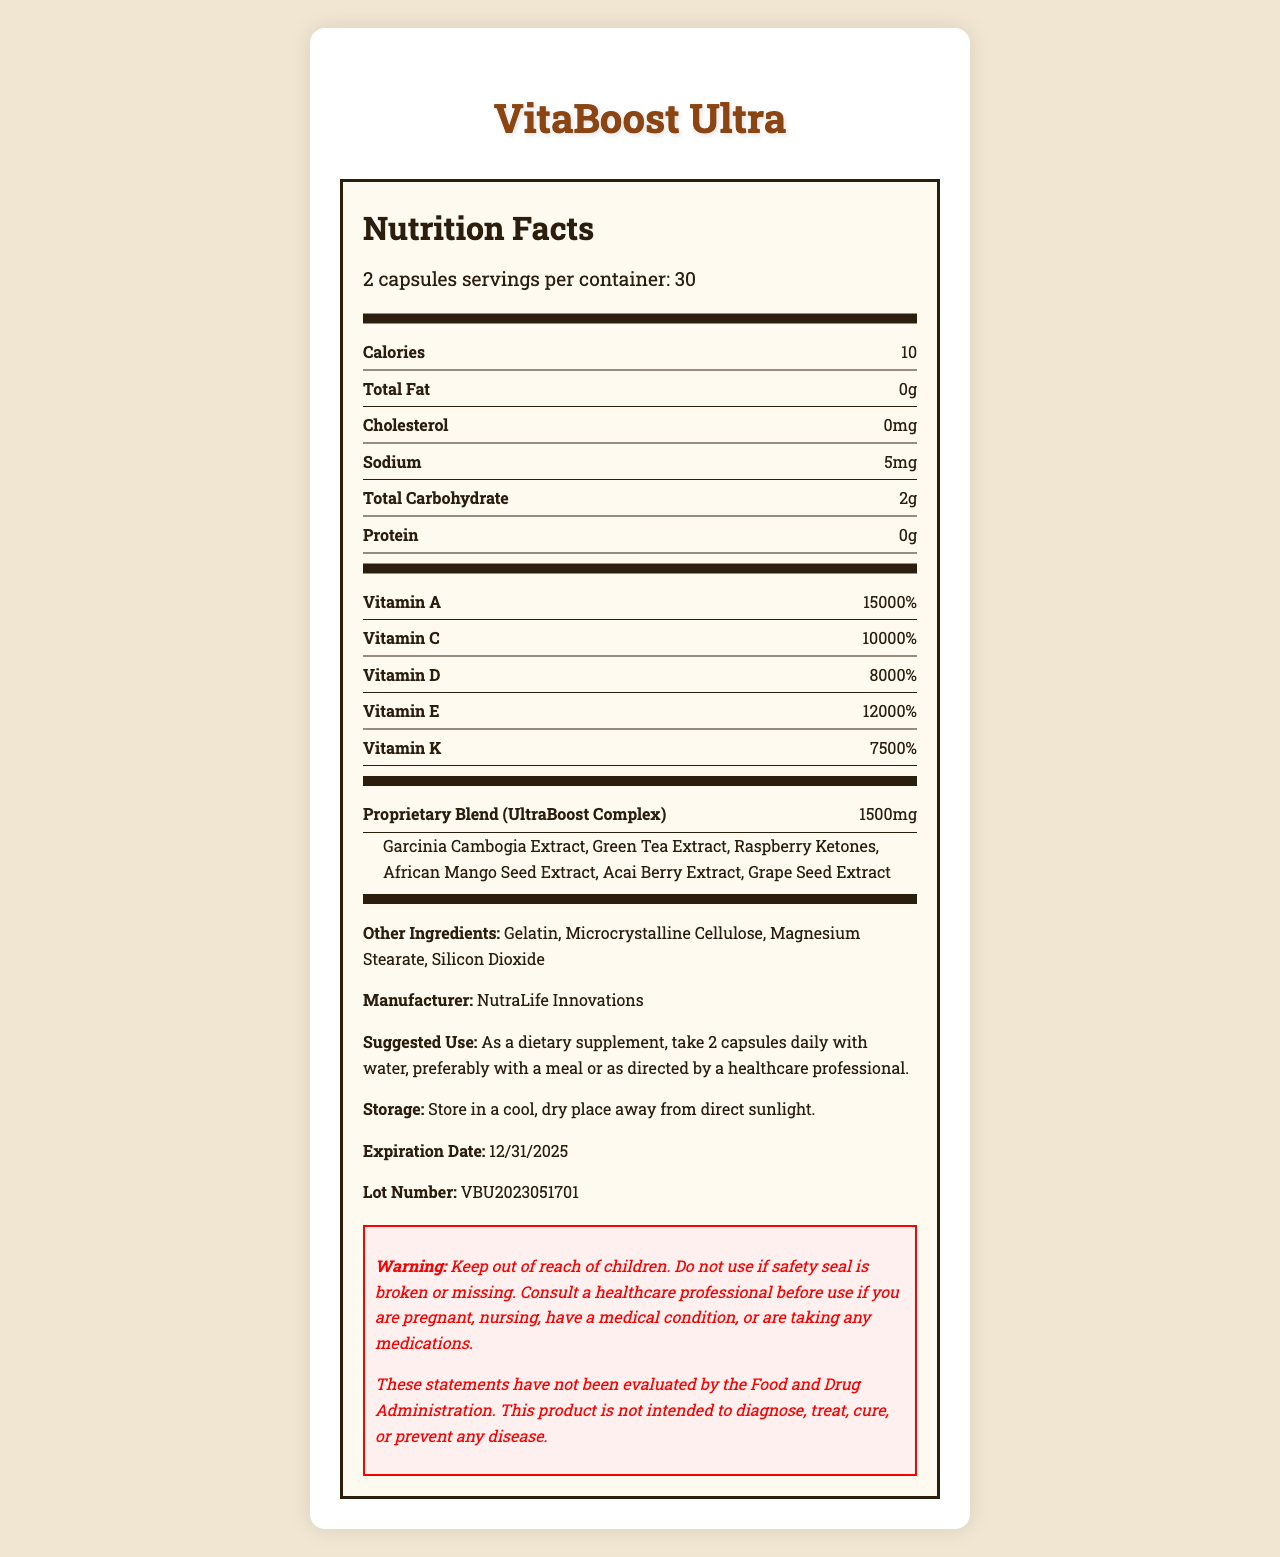what is the product name? The product name is clearly stated at the top of the document in a large title.
Answer: VitaBoost Ultra what is the suggested use? This information is found under the "Suggested Use" section of the document.
Answer: As a dietary supplement, take 2 capsules daily with water, preferably with a meal or as directed by a healthcare professional. how many servings are in the container? The document specifies that there are 2 capsules per serving, with 30 servings per container.
Answer: 30 servings what is the serving size? This is listed under the "Serving Info" section and indicates that the serving size is 2 capsules.
Answer: 2 capsules what is the calorie content per serving? This information is detailed in the first line under the "Nutrition Facts" section in the document.
Answer: 10 calories what is the sodium content per serving? The document lists sodium content as 5mg per serving in the "Nutrition Facts" section.
Answer: 5mg what is the manufacturer of the product? This information is located at the bottom of the document in the "Manufacturer" section.
Answer: NutraLife Innovations what is the expiration date of the product? The expiration date is mentioned under the storage and lot number section near the end of the document.
Answer: 12/31/2025 what vitamins have the highest percentage daily value? A. Vitamin A and Vitamin C B. Vitamin B12 and Biotin C. Vitamin D and Vitamin E Vitamin B12 (20000%) and Biotin (16000%) have the highest percentage daily values, more than Vitamin A (15000%) and others.
Answer: B how much proprietary blend is in each serving? A. 1200mg B. 1500mg C. 1800mg D. 2000mg The proprietary blend amount is specified as 1500mg in the "UltraBoost Complex" section.
Answer: B are there any warnings for pregnant women on this label? The warning section advises consulting a healthcare professional before use if pregnant or nursing.
Answer: Yes is the document about a prescription medication? The document is about a dietary supplement and explicitly states it's not intended to diagnose, treat, cure, or prevent any disease.
Answer: No summarize the contents of the entire document This summary captures all the main sections and details found within the document.
Answer: The document is a Nutrition Facts label for VitaBoost Ultra, a dietary supplement by NutraLife Innovations. It lists serving size, nutritional information, high percentage daily values for various vitamins and minerals, proprietary blend details, other ingredients, manufacturer information, suggested use, storage instructions, expiration date, lot number, a warning, FDA disclaimer, and contact information. what is the exact mailing address of the manufacturer? The mailing address is found in the contact info section.
Answer: 123 Health Boulevard, Wellness City, CA 90210 how much vitamin C is present per serving as a percentage of the daily value? The vitamin C content is listed as 10000% in the "Nutrition Facts" section.
Answer: 10000% how much fat does the product contain per serving? The total fat content is shown as 0g per serving in the "Nutrition Facts" section.
Answer: 0g what is the total carbohydrate content per serving? This information is listed under the "Nutrition Facts" section on the label.
Answer: 2g what is the lot number of the product? The lot number is listed at the end of the document under the storage instructions section.
Answer: VBU2023051701 who should you consult before using this product if you are taking any medications? The warning section advises consulting a healthcare professional if you are taking any medications.
Answer: A healthcare professional what is the barcode number of the product? The barcode number is displayed at the bottom of the document near the contact information.
Answer: 890123456789 does the product contain any gelatin? Gelatin is listed under "Other Ingredients" in the document.
Answer: Yes why is this product's nutritional information raising concerns? The percentages daily values for multiple vitamins and minerals are suspiciously high, which might not be accurate and could be misleading.
Answer: The excessively high values for vitamins and minerals could indicate potential fraudulent health claims. how many calories come from protein? The document indicates that there is 0g of protein per serving, so no calories come from protein.
Answer: 0 calories what are the proprietary blend ingredients? These ingredients are listed under the "UltraBoost Complex" section in the proprietary blend.
Answer: Garcinia Cambogia Extract, Green Tea Extract, Raspberry Ketones, African Mango Seed Extract, Acai Berry Extract, Grape Seed Extract 